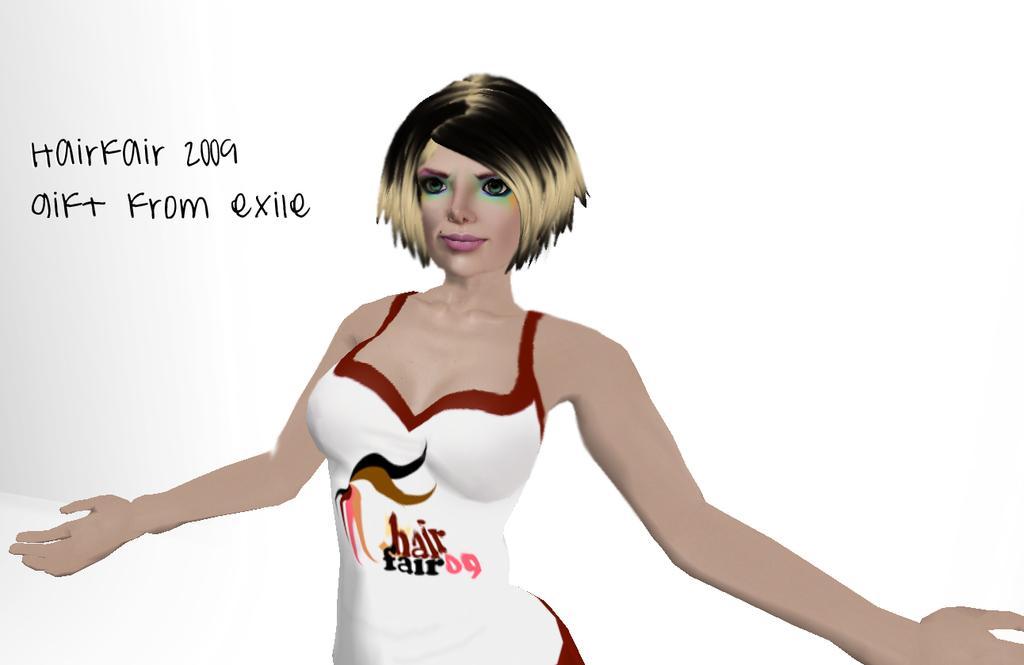Could you give a brief overview of what you see in this image? In this image I see the depiction of a woman who is wearing white and red color dress and I see something is written over here and it is white in the background and I see something is written over here too. 